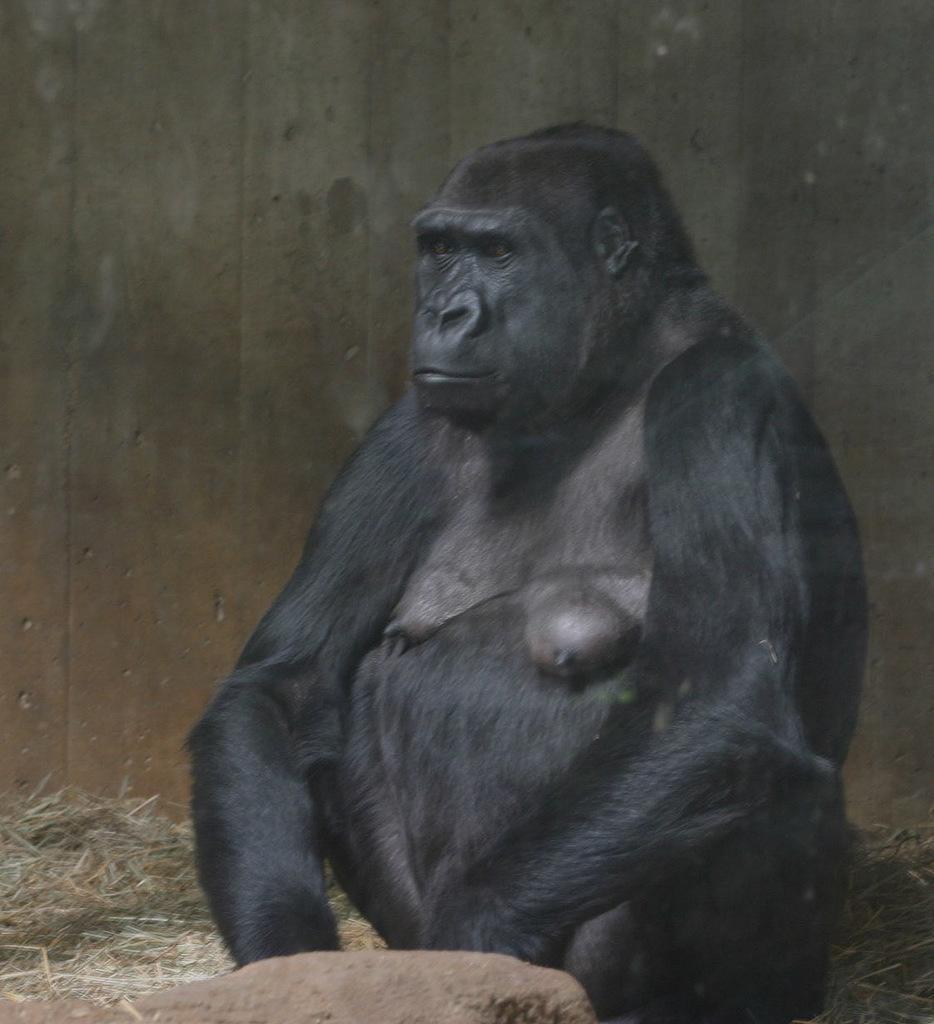Describe this image in one or two sentences. In this picture we can observe a gorilla which is in black color. This girl is sitting on the ground. There is some dried grass on the left side. In the background there is a wooden wall. 